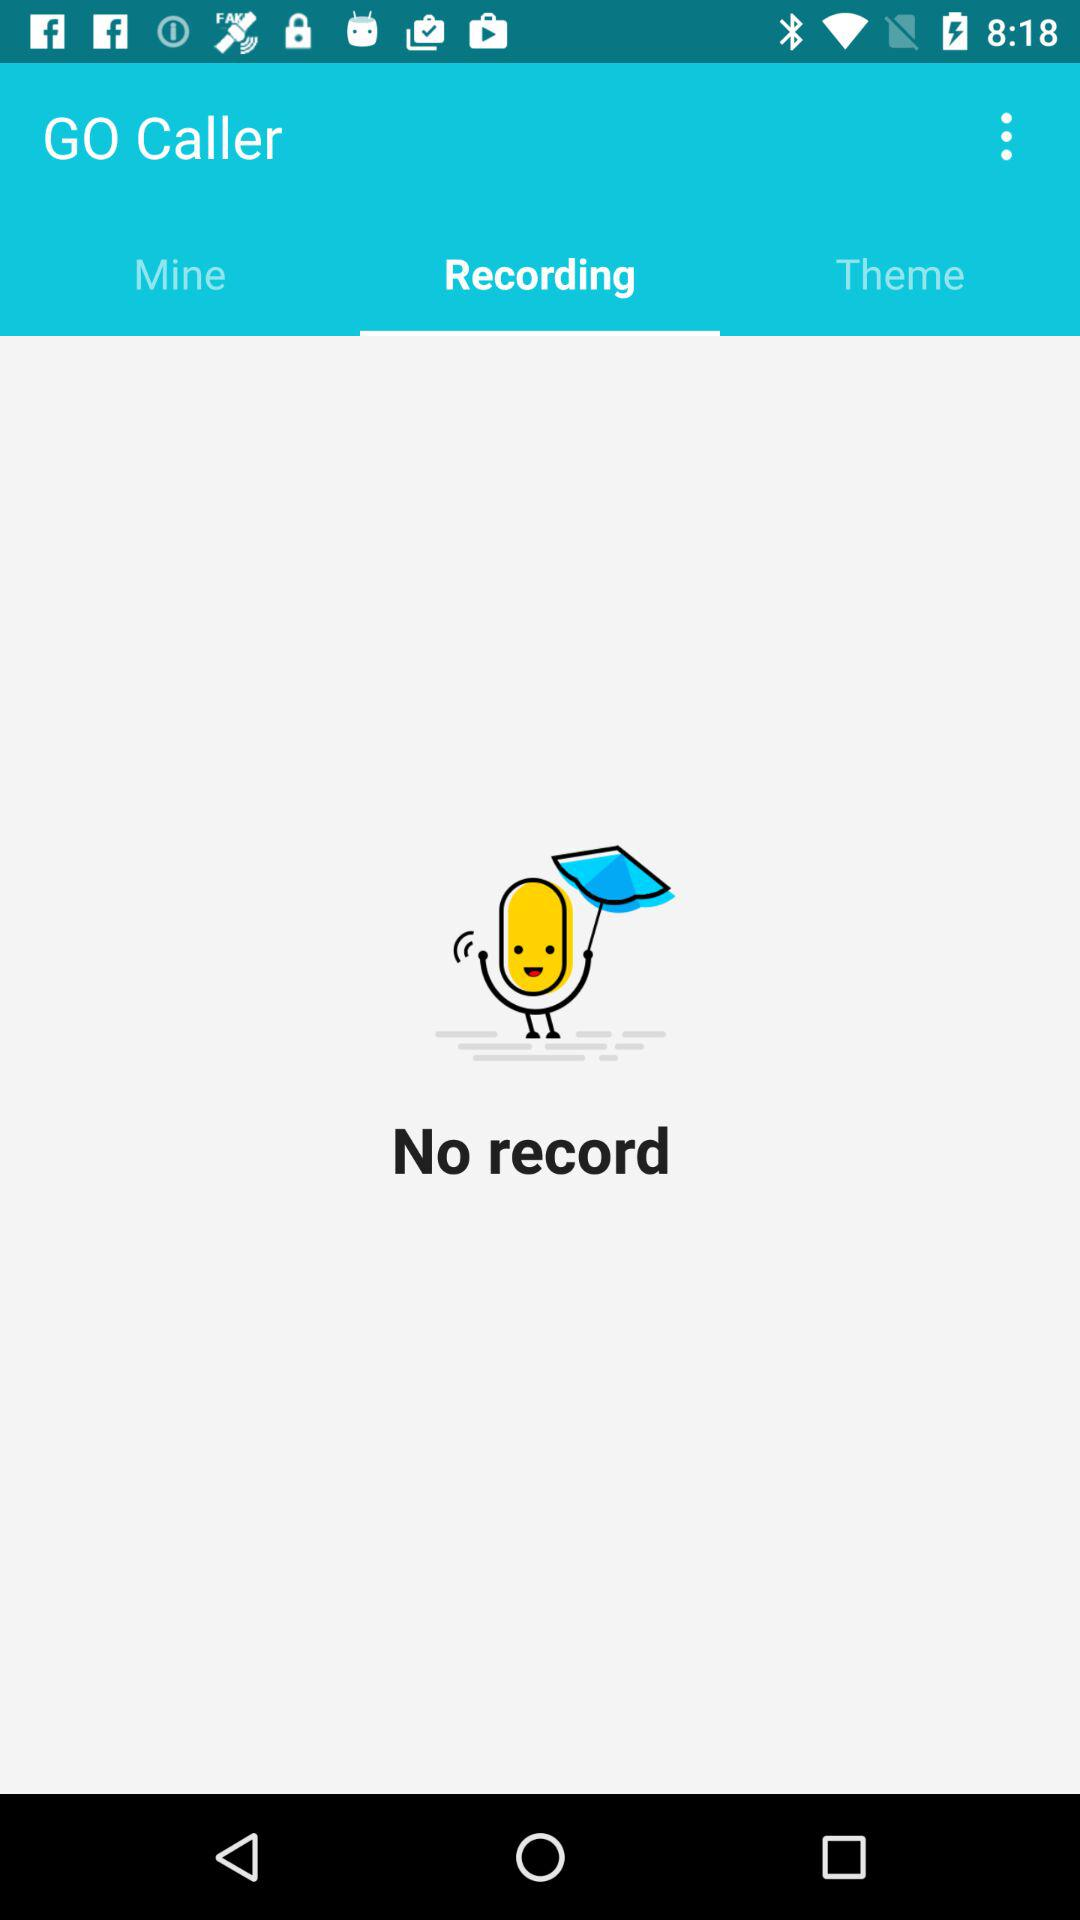How many recordings are there? There are no recordings. 